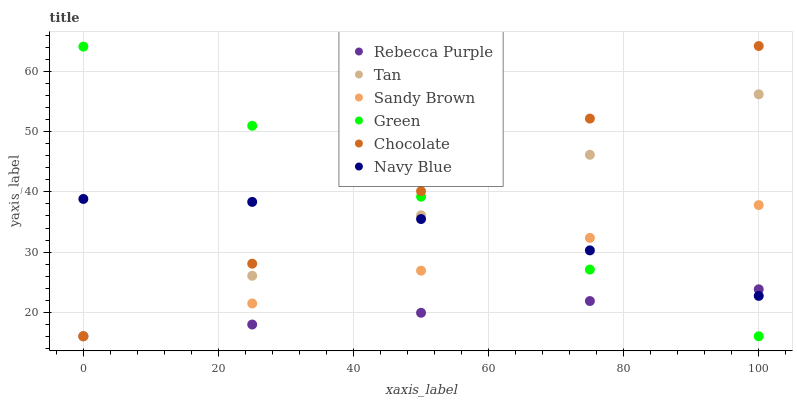Does Rebecca Purple have the minimum area under the curve?
Answer yes or no. Yes. Does Chocolate have the maximum area under the curve?
Answer yes or no. Yes. Does Green have the minimum area under the curve?
Answer yes or no. No. Does Green have the maximum area under the curve?
Answer yes or no. No. Is Chocolate the smoothest?
Answer yes or no. Yes. Is Navy Blue the roughest?
Answer yes or no. Yes. Is Green the smoothest?
Answer yes or no. No. Is Green the roughest?
Answer yes or no. No. Does Chocolate have the lowest value?
Answer yes or no. Yes. Does Chocolate have the highest value?
Answer yes or no. Yes. Does Green have the highest value?
Answer yes or no. No. Does Rebecca Purple intersect Navy Blue?
Answer yes or no. Yes. Is Rebecca Purple less than Navy Blue?
Answer yes or no. No. Is Rebecca Purple greater than Navy Blue?
Answer yes or no. No. 